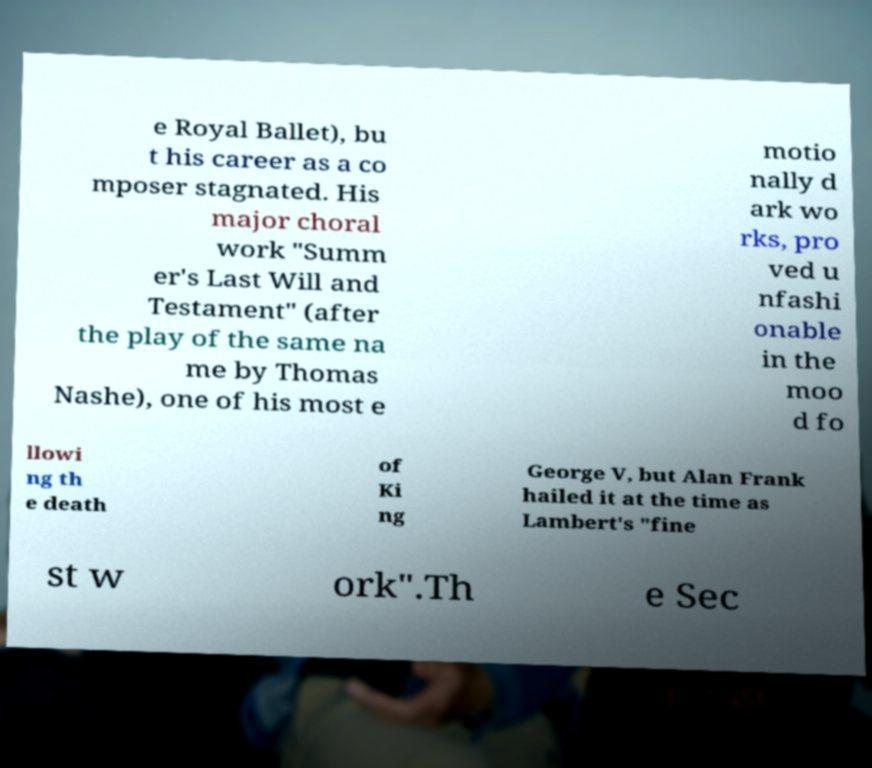Please identify and transcribe the text found in this image. e Royal Ballet), bu t his career as a co mposer stagnated. His major choral work "Summ er's Last Will and Testament" (after the play of the same na me by Thomas Nashe), one of his most e motio nally d ark wo rks, pro ved u nfashi onable in the moo d fo llowi ng th e death of Ki ng George V, but Alan Frank hailed it at the time as Lambert's "fine st w ork".Th e Sec 